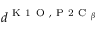<formula> <loc_0><loc_0><loc_500><loc_500>d ^ { K 1 O , P 2 C _ { \beta } }</formula> 